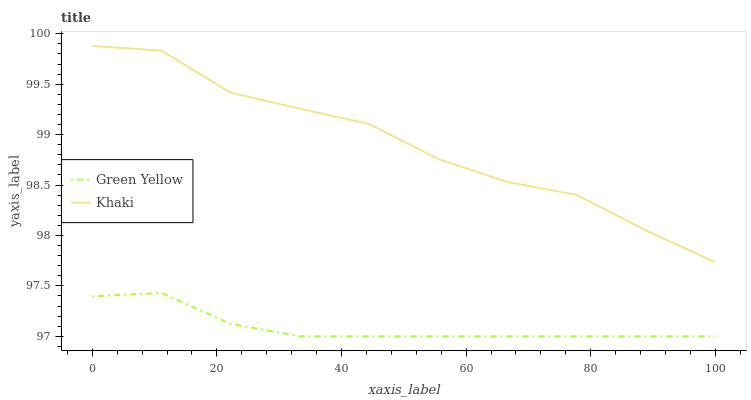Does Khaki have the minimum area under the curve?
Answer yes or no. No. Is Khaki the smoothest?
Answer yes or no. No. Does Khaki have the lowest value?
Answer yes or no. No. Is Green Yellow less than Khaki?
Answer yes or no. Yes. Is Khaki greater than Green Yellow?
Answer yes or no. Yes. Does Green Yellow intersect Khaki?
Answer yes or no. No. 